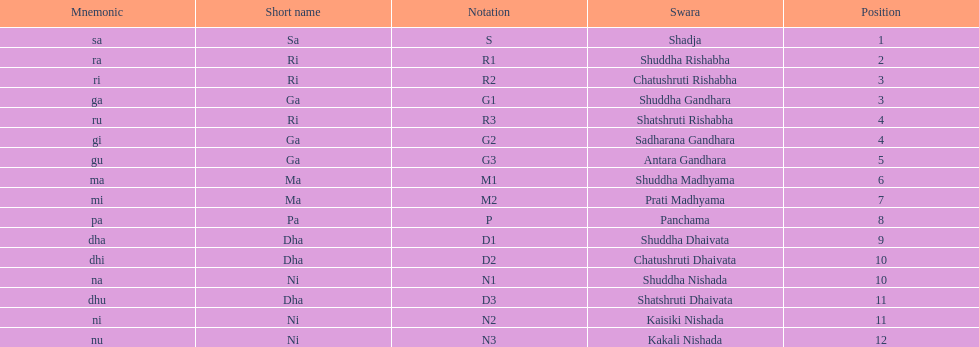Which swara holds the last position? Kakali Nishada. 